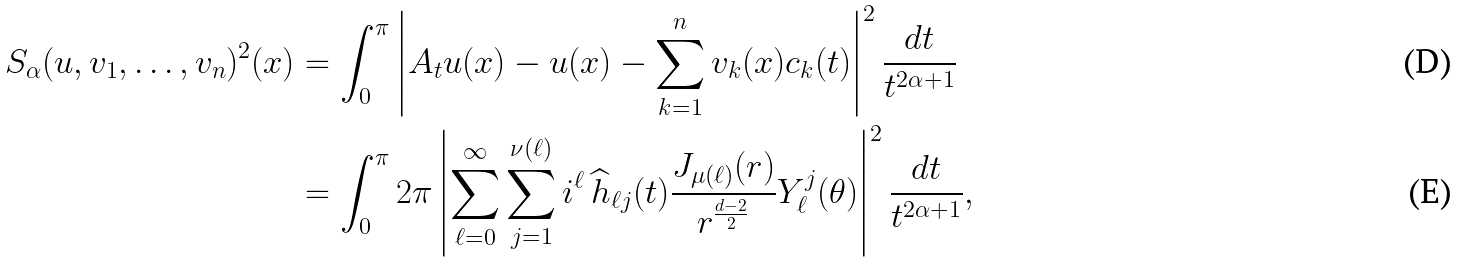Convert formula to latex. <formula><loc_0><loc_0><loc_500><loc_500>S _ { \alpha } ( u , v _ { 1 } , \dots , v _ { n } ) ^ { 2 } ( x ) & = \int _ { 0 } ^ { \pi } \left | A _ { t } u ( x ) - u ( x ) - \sum _ { k = 1 } ^ { n } v _ { k } ( x ) c _ { k } ( t ) \right | ^ { 2 } \frac { d t } { t ^ { 2 \alpha + 1 } } \\ & = \int _ { 0 } ^ { \pi } 2 \pi \left | \sum _ { \ell = 0 } ^ { \infty } \sum _ { j = 1 } ^ { \nu ( \ell ) } i ^ { \ell } \, \widehat { h } _ { \ell j } ( t ) \frac { J _ { \mu ( \ell ) } ( r ) } { r ^ { \frac { d - 2 } { 2 } } } Y _ { \ell } ^ { j } ( \theta ) \right | ^ { 2 } \frac { d t } { t ^ { 2 \alpha + 1 } } ,</formula> 